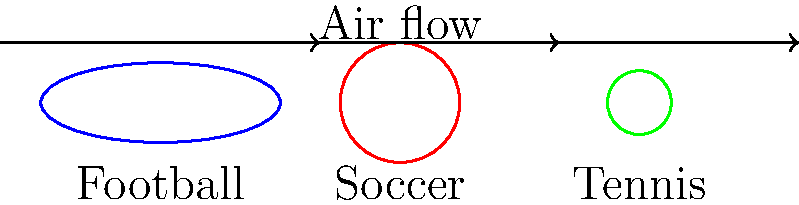Based on the cross-sectional diagrams of different sports balls shown above, which ball would likely experience the least air resistance during flight? To answer this question, we need to consider the principles of aerodynamics and how they apply to the shapes of these sports balls:

1. Air resistance (drag) is affected by the shape and size of an object moving through the air.

2. A more streamlined shape experiences less air resistance.

3. Looking at the cross-sectional diagrams:
   - The football (rugby ball) has an elliptical shape.
   - The soccer ball has a circular shape.
   - The tennis ball has a smaller circular shape.

4. The football's elliptical shape is more streamlined, allowing air to flow around it more easily.

5. Both the soccer and tennis balls have circular cross-sections, which are less aerodynamic than the elliptical shape.

6. Between the soccer and tennis balls, the tennis ball is smaller, which means it has a smaller frontal area exposed to the air flow.

7. A smaller frontal area results in less air resistance.

Therefore, while the football has a good aerodynamic shape, the tennis ball's significantly smaller size gives it an advantage in experiencing the least air resistance during flight.
Answer: Tennis ball 